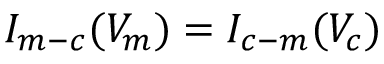Convert formula to latex. <formula><loc_0><loc_0><loc_500><loc_500>I _ { m - c } ( V _ { m } ) = I _ { c - m } ( V _ { c } )</formula> 